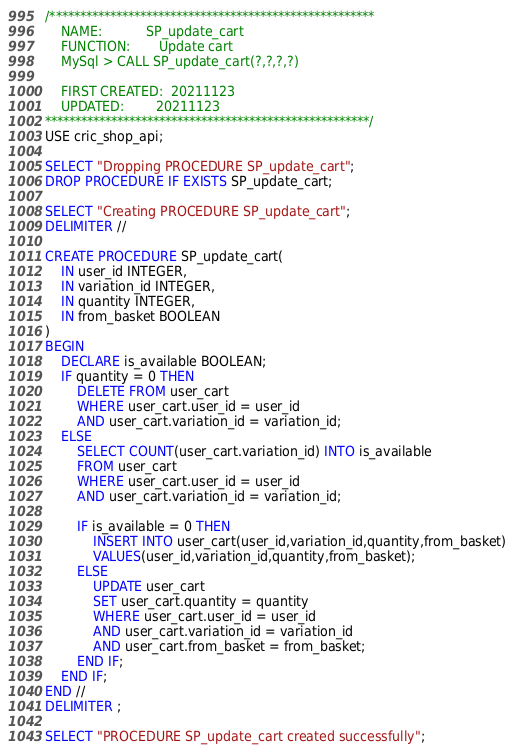<code> <loc_0><loc_0><loc_500><loc_500><_SQL_>/******************************************************
	NAME:           SP_update_cart
 	FUNCTION:       Update cart
 	MySql > CALL SP_update_cart(?,?,?,?) 
	
 	FIRST CREATED:  20211123
 	UPDATED:        20211123
******************************************************/
USE cric_shop_api;

SELECT "Dropping PROCEDURE SP_update_cart";
DROP PROCEDURE IF EXISTS SP_update_cart;

SELECT "Creating PROCEDURE SP_update_cart";
DELIMITER //

CREATE PROCEDURE SP_update_cart(
	IN user_id INTEGER,
	IN variation_id INTEGER,
	IN quantity INTEGER,
	IN from_basket BOOLEAN
) 
BEGIN
	DECLARE is_available BOOLEAN;
	IF quantity = 0 THEN
		DELETE FROM user_cart 
		WHERE user_cart.user_id = user_id
		AND user_cart.variation_id = variation_id;
	ELSE 
		SELECT COUNT(user_cart.variation_id) INTO is_available 
		FROM user_cart
		WHERE user_cart.user_id = user_id
		AND user_cart.variation_id = variation_id;

		IF is_available = 0 THEN 
			INSERT INTO user_cart(user_id,variation_id,quantity,from_basket) 
			VALUES(user_id,variation_id,quantity,from_basket);
		ELSE 
			UPDATE user_cart 
			SET user_cart.quantity = quantity
			WHERE user_cart.user_id = user_id
			AND user_cart.variation_id = variation_id
			AND user_cart.from_basket = from_basket;
		END IF;
	END IF;
END //
DELIMITER ;

SELECT "PROCEDURE SP_update_cart created successfully";</code> 